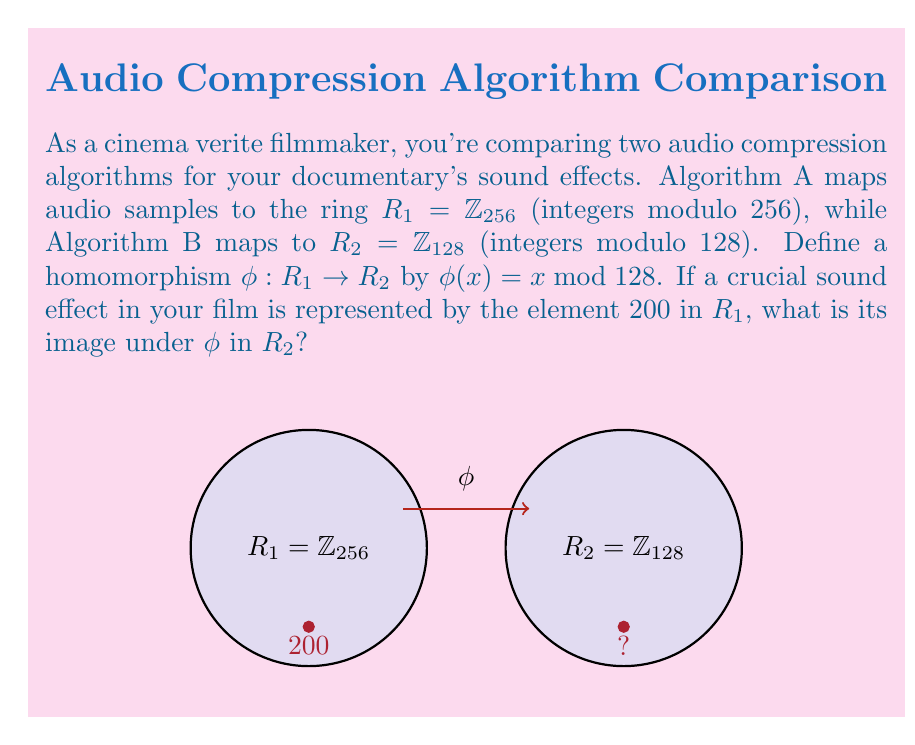Give your solution to this math problem. To solve this problem, we need to follow these steps:

1) Understand the homomorphism:
   The function $\phi: R_1 \rightarrow R_2$ is defined as $\phi(x) = x \bmod 128$.
   This means we need to find the remainder when $x$ is divided by 128.

2) Apply the homomorphism to the given element:
   We need to find $\phi(200)$.

3) Calculate 200 mod 128:
   $200 = 1 \times 128 + 72$
   Therefore, $200 \bmod 128 = 72$

4) Verify the result:
   72 is indeed an element of $R_2 = \mathbb{Z}_{128}$ as it's between 0 and 127.

This homomorphism effectively "wraps" the elements of $R_1$ onto $R_2$, preserving the algebraic structure. In the context of audio compression, this could represent a reduction in the bit depth of the audio samples, potentially resulting in some loss of audio quality but a smaller file size.
Answer: $\phi(200) = 72$ 